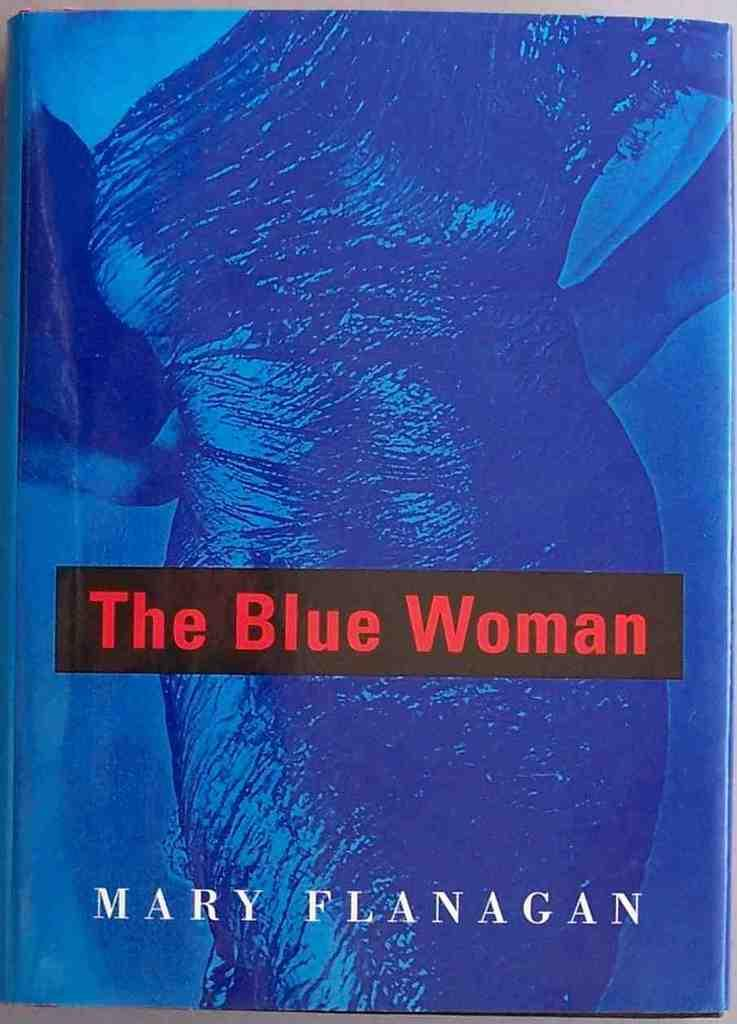What object can be seen in the image? There is a book in the image. What is the color of the book? The book is blue in color. Is there any person depicted on the book? Yes, there is a person depicted on the book. Can you read any text on the book? There is text visible on the book. What type of quiver is the person holding in the image? There is no person holding a quiver in the image; the book only depicts a person, not any objects they might be holding. 